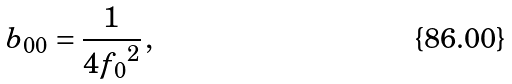<formula> <loc_0><loc_0><loc_500><loc_500>b _ { 0 0 } = \frac { 1 } { 4 { f _ { 0 } } ^ { 2 } } \, ,</formula> 